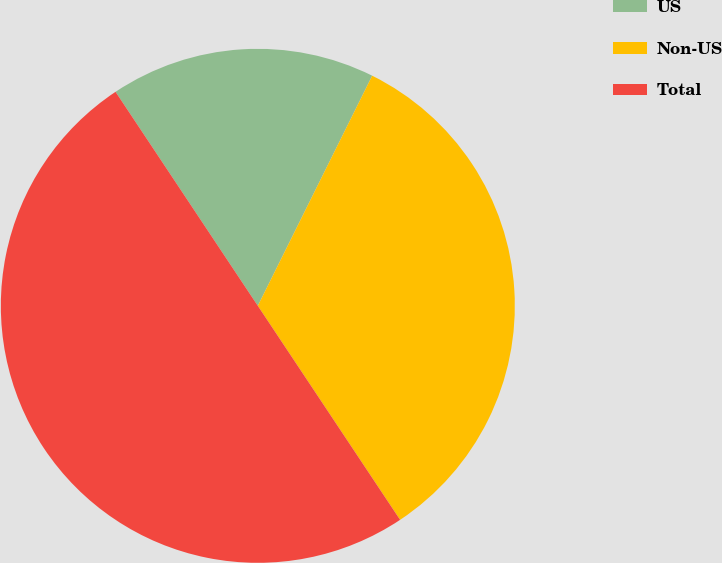Convert chart. <chart><loc_0><loc_0><loc_500><loc_500><pie_chart><fcel>US<fcel>Non-US<fcel>Total<nl><fcel>16.68%<fcel>33.32%<fcel>50.0%<nl></chart> 